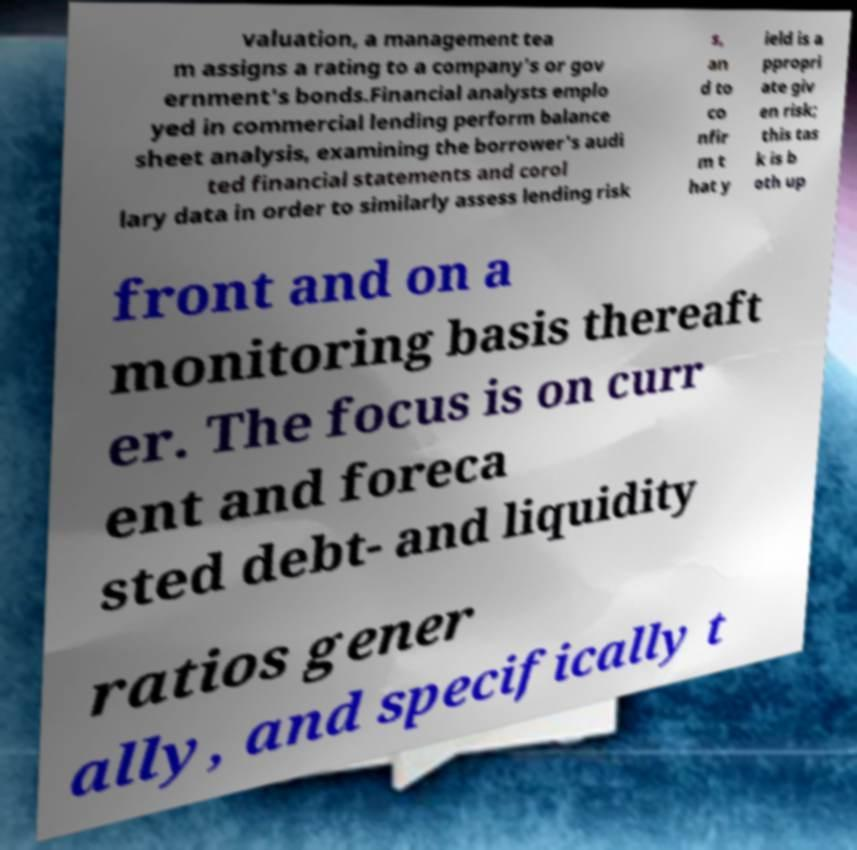For documentation purposes, I need the text within this image transcribed. Could you provide that? valuation, a management tea m assigns a rating to a company's or gov ernment's bonds.Financial analysts emplo yed in commercial lending perform balance sheet analysis, examining the borrower's audi ted financial statements and corol lary data in order to similarly assess lending risk s, an d to co nfir m t hat y ield is a ppropri ate giv en risk; this tas k is b oth up front and on a monitoring basis thereaft er. The focus is on curr ent and foreca sted debt- and liquidity ratios gener ally, and specifically t 